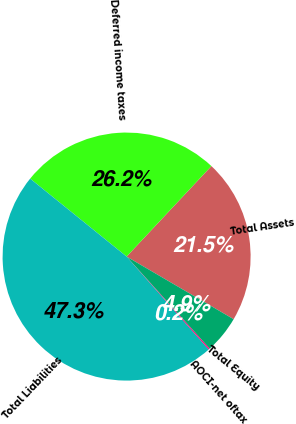Convert chart to OTSL. <chart><loc_0><loc_0><loc_500><loc_500><pie_chart><fcel>Total Assets<fcel>Deferred income taxes<fcel>Total Liabilities<fcel>AOCI-net oftax<fcel>Total Equity<nl><fcel>21.45%<fcel>26.16%<fcel>47.34%<fcel>0.17%<fcel>4.88%<nl></chart> 